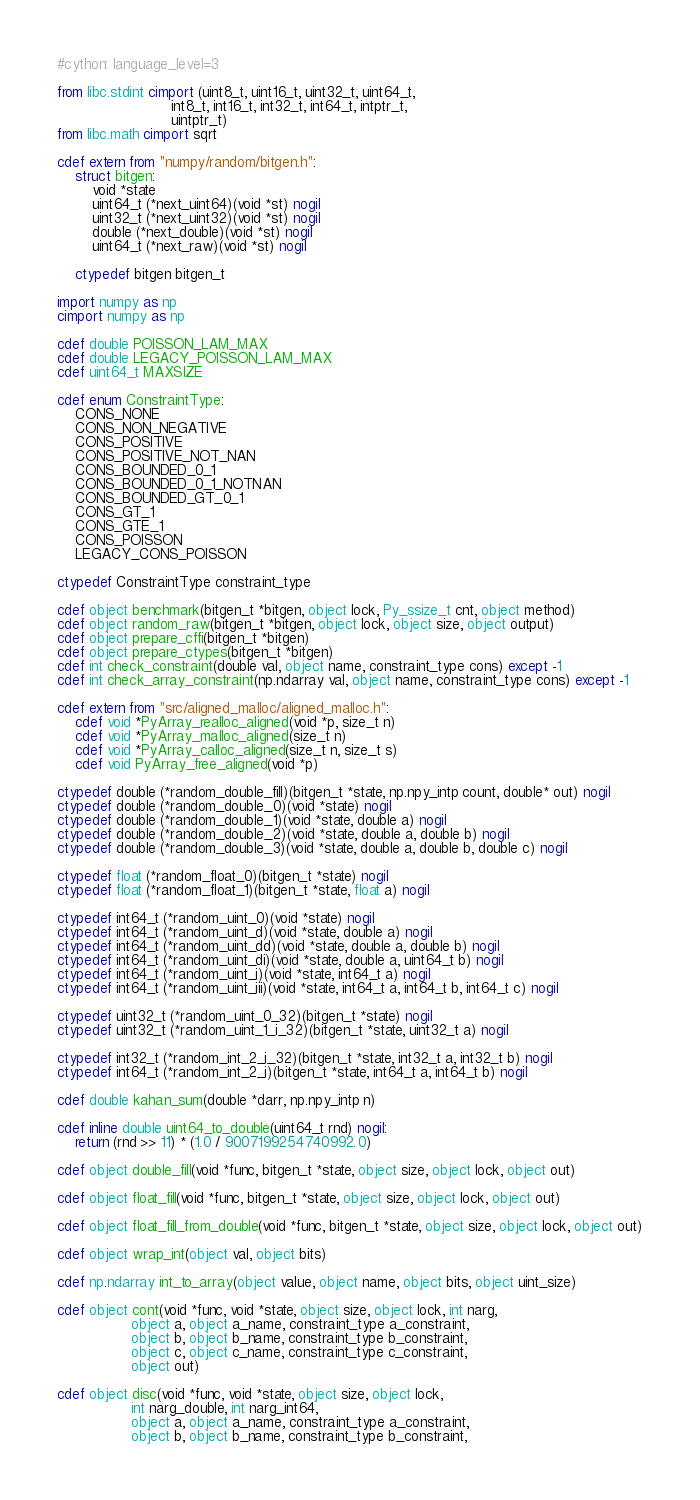Convert code to text. <code><loc_0><loc_0><loc_500><loc_500><_Cython_>#cython: language_level=3

from libc.stdint cimport (uint8_t, uint16_t, uint32_t, uint64_t,
                          int8_t, int16_t, int32_t, int64_t, intptr_t,
                          uintptr_t)
from libc.math cimport sqrt

cdef extern from "numpy/random/bitgen.h":
    struct bitgen:
        void *state
        uint64_t (*next_uint64)(void *st) nogil
        uint32_t (*next_uint32)(void *st) nogil
        double (*next_double)(void *st) nogil
        uint64_t (*next_raw)(void *st) nogil

    ctypedef bitgen bitgen_t

import numpy as np
cimport numpy as np

cdef double POISSON_LAM_MAX
cdef double LEGACY_POISSON_LAM_MAX
cdef uint64_t MAXSIZE

cdef enum ConstraintType:
    CONS_NONE
    CONS_NON_NEGATIVE
    CONS_POSITIVE
    CONS_POSITIVE_NOT_NAN
    CONS_BOUNDED_0_1
    CONS_BOUNDED_0_1_NOTNAN
    CONS_BOUNDED_GT_0_1
    CONS_GT_1
    CONS_GTE_1
    CONS_POISSON
    LEGACY_CONS_POISSON

ctypedef ConstraintType constraint_type

cdef object benchmark(bitgen_t *bitgen, object lock, Py_ssize_t cnt, object method)
cdef object random_raw(bitgen_t *bitgen, object lock, object size, object output)
cdef object prepare_cffi(bitgen_t *bitgen)
cdef object prepare_ctypes(bitgen_t *bitgen)
cdef int check_constraint(double val, object name, constraint_type cons) except -1
cdef int check_array_constraint(np.ndarray val, object name, constraint_type cons) except -1

cdef extern from "src/aligned_malloc/aligned_malloc.h":
    cdef void *PyArray_realloc_aligned(void *p, size_t n)
    cdef void *PyArray_malloc_aligned(size_t n)
    cdef void *PyArray_calloc_aligned(size_t n, size_t s)
    cdef void PyArray_free_aligned(void *p)

ctypedef double (*random_double_fill)(bitgen_t *state, np.npy_intp count, double* out) nogil
ctypedef double (*random_double_0)(void *state) nogil
ctypedef double (*random_double_1)(void *state, double a) nogil
ctypedef double (*random_double_2)(void *state, double a, double b) nogil
ctypedef double (*random_double_3)(void *state, double a, double b, double c) nogil

ctypedef float (*random_float_0)(bitgen_t *state) nogil
ctypedef float (*random_float_1)(bitgen_t *state, float a) nogil

ctypedef int64_t (*random_uint_0)(void *state) nogil
ctypedef int64_t (*random_uint_d)(void *state, double a) nogil
ctypedef int64_t (*random_uint_dd)(void *state, double a, double b) nogil
ctypedef int64_t (*random_uint_di)(void *state, double a, uint64_t b) nogil
ctypedef int64_t (*random_uint_i)(void *state, int64_t a) nogil
ctypedef int64_t (*random_uint_iii)(void *state, int64_t a, int64_t b, int64_t c) nogil

ctypedef uint32_t (*random_uint_0_32)(bitgen_t *state) nogil
ctypedef uint32_t (*random_uint_1_i_32)(bitgen_t *state, uint32_t a) nogil

ctypedef int32_t (*random_int_2_i_32)(bitgen_t *state, int32_t a, int32_t b) nogil
ctypedef int64_t (*random_int_2_i)(bitgen_t *state, int64_t a, int64_t b) nogil

cdef double kahan_sum(double *darr, np.npy_intp n)

cdef inline double uint64_to_double(uint64_t rnd) nogil:
    return (rnd >> 11) * (1.0 / 9007199254740992.0)

cdef object double_fill(void *func, bitgen_t *state, object size, object lock, object out)

cdef object float_fill(void *func, bitgen_t *state, object size, object lock, object out)

cdef object float_fill_from_double(void *func, bitgen_t *state, object size, object lock, object out)

cdef object wrap_int(object val, object bits)

cdef np.ndarray int_to_array(object value, object name, object bits, object uint_size)

cdef object cont(void *func, void *state, object size, object lock, int narg,
                 object a, object a_name, constraint_type a_constraint,
                 object b, object b_name, constraint_type b_constraint,
                 object c, object c_name, constraint_type c_constraint,
                 object out)

cdef object disc(void *func, void *state, object size, object lock,
                 int narg_double, int narg_int64,
                 object a, object a_name, constraint_type a_constraint,
                 object b, object b_name, constraint_type b_constraint,</code> 